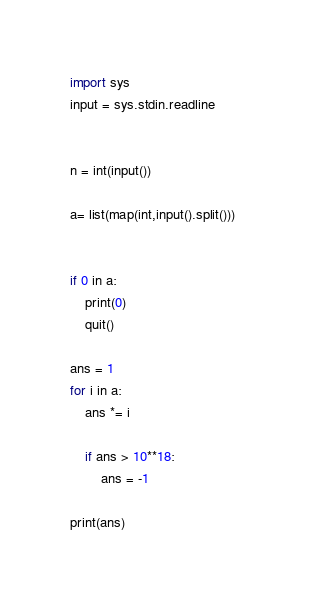<code> <loc_0><loc_0><loc_500><loc_500><_Python_>import sys 
input = sys.stdin.readline
 
 
n = int(input())
 
a= list(map(int,input().split())) 
 

if 0 in a:
    print(0)
    quit()
 
ans = 1
for i in a:
    ans *= i 
    
    if ans > 10**18:
        ans = -1

print(ans) 
</code> 